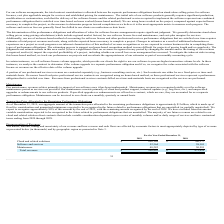According to Csg Systems International's financial document, What is a factor affecting the nature, amount, timing and uncertainty of the company's revenue? According to the financial document, Maintenance. The relevant text states: "Maintenance 48,282 50,581..." Also, What is the amount of cash flow pertaining to maintenance in 2019? According to the financial document, 48,282 (in thousands). The relevant text states: "Maintenance 48,282 50,581..." Also, What is the amount of revenue earned by the company in 2019? According to the financial document, $996,810 (in thousands). The relevant text states: "Total revenues $ 996,810 $ 875,059..." Also, can you calculate: What is the percentage change in revenue between 2018 and 2019? To answer this question, I need to perform calculations using the financial data. The calculation is: (996,810-875,059)/875,059, which equals 13.91 (percentage). This is based on the information: "Total revenues $ 996,810 $ 875,059 Total revenues $ 996,810 $ 875,059..." The key data points involved are: 875,059, 996,810. Also, can you calculate: What is the proportion of total revenue arising from cloud and related solutions in 2019? Based on the calculation: 896,164/996,810 , the result is 89.9 (percentage). This is based on the information: "Cloud and related solutions $ 896,164 $ 766,377 Total revenues $ 996,810 $ 875,059..." The key data points involved are: 896,164, 996,810. Also, can you calculate: What is the total revenue earned from 2018 to 2019? Based on the calculation: $875,059+$996,810 , the result is 1871869 (in thousands). This is based on the information: "Total revenues $ 996,810 $ 875,059 Total revenues $ 996,810 $ 875,059..." The key data points involved are: 875,059, 996,810. 